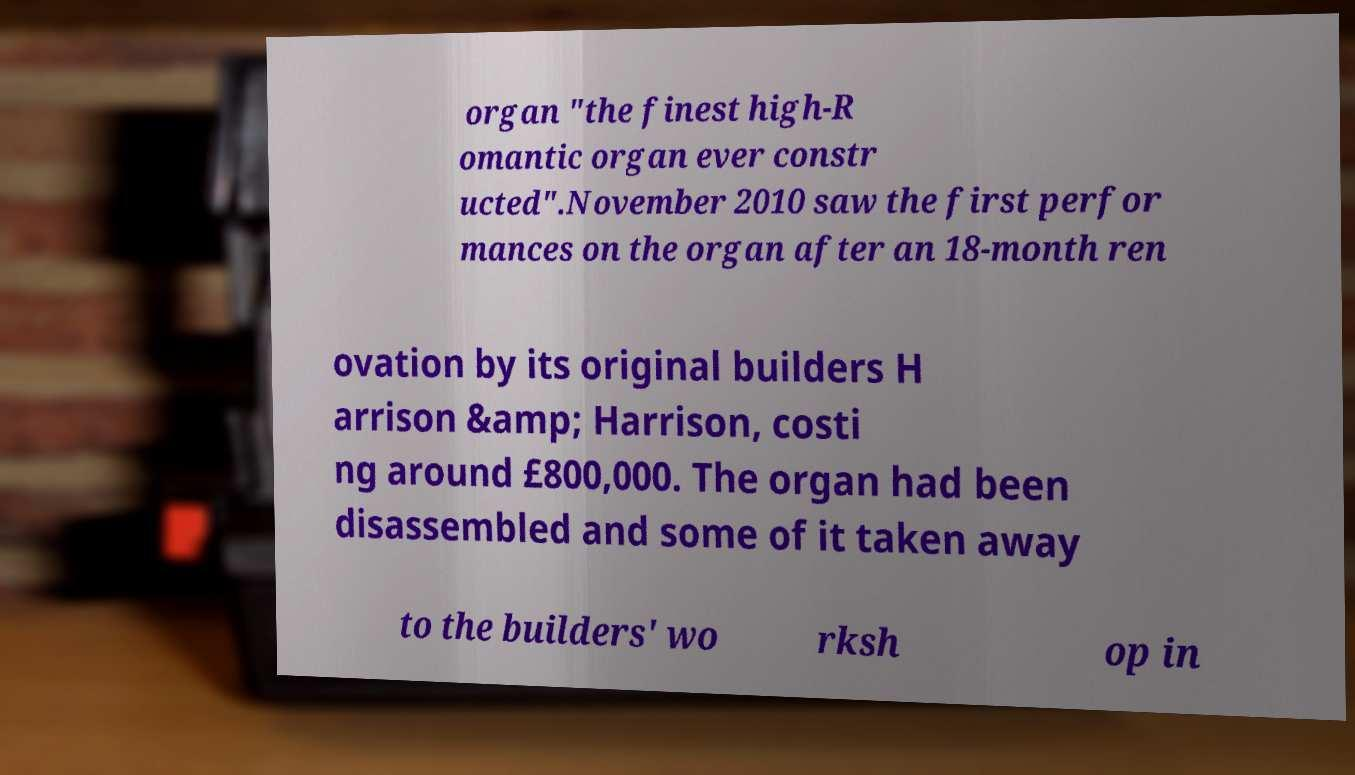What messages or text are displayed in this image? I need them in a readable, typed format. organ "the finest high-R omantic organ ever constr ucted".November 2010 saw the first perfor mances on the organ after an 18-month ren ovation by its original builders H arrison &amp; Harrison, costi ng around £800,000. The organ had been disassembled and some of it taken away to the builders' wo rksh op in 